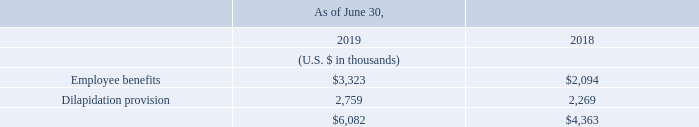Non-current provisions
Non-current provisions consisted of the following:
The non-current provision for employee benefits includes long service leave as described above.
The dilapidation provision relates to certain lease arrangements for office space entered into by the Group. These lease arrangements require the Group to restore each premises to its original condition upon lease termination. Accordingly, the Group records a provision for the present value of the estimated future costs to retire long-lived assets at the expiration of these leases.
What does the dilapidation provision relate to? Certain lease arrangements for office space entered into by the group. What is the total non-current provisions for fiscal years 2018 and 2019 respectively?
Answer scale should be: thousand. $4,363, $6,082. What is the dilapidation provision for fiscal year 2019?
Answer scale should be: thousand. 2,759. What is the average employee benefits for fiscal years 2018 and 2019?
Answer scale should be: thousand. (3,323+2,094)/2
Answer: 2708.5. What is the difference in the total non-current provision between fiscal years 2018 and 2019?
Answer scale should be: thousand. 6,082-4,363
Answer: 1719. In fiscal year 2019, what is the percentage constitution of employee benefits among the total non-current provisions?
Answer scale should be: percent. 3,323/6,082
Answer: 54.64. 